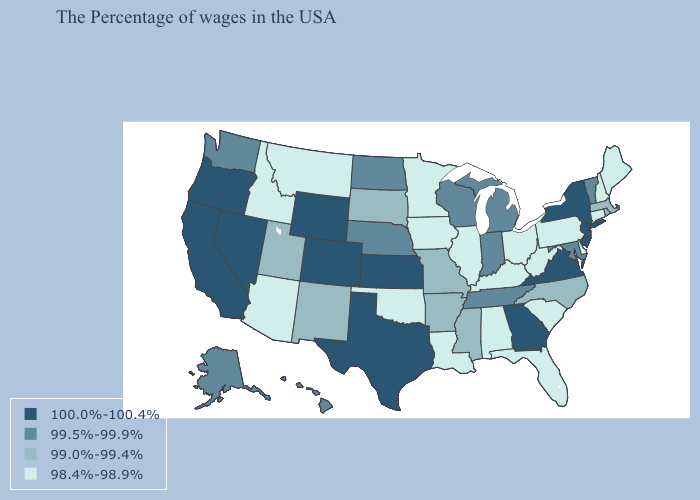Name the states that have a value in the range 98.4%-98.9%?
Quick response, please. Maine, New Hampshire, Connecticut, Delaware, Pennsylvania, South Carolina, West Virginia, Ohio, Florida, Kentucky, Alabama, Illinois, Louisiana, Minnesota, Iowa, Oklahoma, Montana, Arizona, Idaho. Among the states that border Kentucky , does Indiana have the lowest value?
Write a very short answer. No. Which states have the lowest value in the USA?
Give a very brief answer. Maine, New Hampshire, Connecticut, Delaware, Pennsylvania, South Carolina, West Virginia, Ohio, Florida, Kentucky, Alabama, Illinois, Louisiana, Minnesota, Iowa, Oklahoma, Montana, Arizona, Idaho. Does the map have missing data?
Short answer required. No. Does the map have missing data?
Write a very short answer. No. Name the states that have a value in the range 98.4%-98.9%?
Keep it brief. Maine, New Hampshire, Connecticut, Delaware, Pennsylvania, South Carolina, West Virginia, Ohio, Florida, Kentucky, Alabama, Illinois, Louisiana, Minnesota, Iowa, Oklahoma, Montana, Arizona, Idaho. How many symbols are there in the legend?
Give a very brief answer. 4. What is the value of Kansas?
Quick response, please. 100.0%-100.4%. Does the map have missing data?
Quick response, please. No. What is the value of Connecticut?
Write a very short answer. 98.4%-98.9%. Which states hav the highest value in the West?
Quick response, please. Wyoming, Colorado, Nevada, California, Oregon. What is the value of Michigan?
Write a very short answer. 99.5%-99.9%. Name the states that have a value in the range 100.0%-100.4%?
Write a very short answer. New York, New Jersey, Virginia, Georgia, Kansas, Texas, Wyoming, Colorado, Nevada, California, Oregon. What is the highest value in states that border Idaho?
Be succinct. 100.0%-100.4%. Which states have the highest value in the USA?
Write a very short answer. New York, New Jersey, Virginia, Georgia, Kansas, Texas, Wyoming, Colorado, Nevada, California, Oregon. 